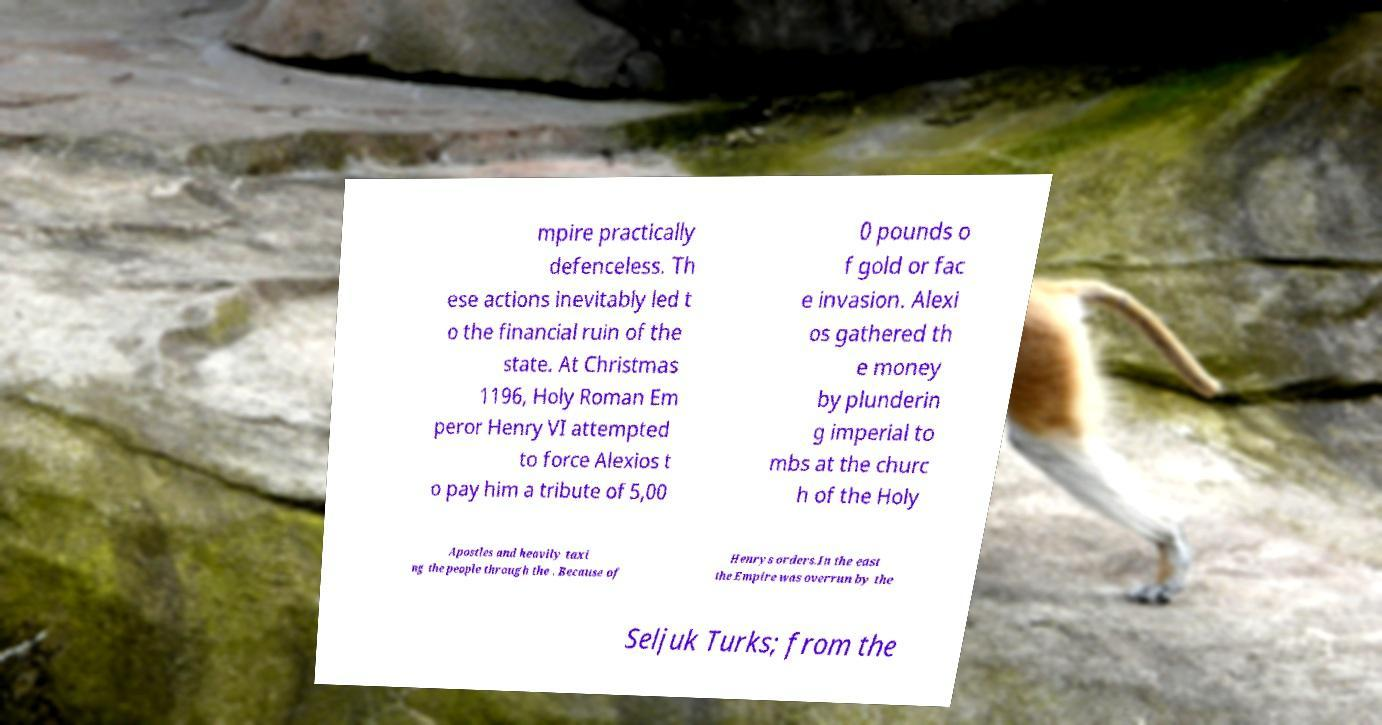Please read and relay the text visible in this image. What does it say? mpire practically defenceless. Th ese actions inevitably led t o the financial ruin of the state. At Christmas 1196, Holy Roman Em peror Henry VI attempted to force Alexios t o pay him a tribute of 5,00 0 pounds o f gold or fac e invasion. Alexi os gathered th e money by plunderin g imperial to mbs at the churc h of the Holy Apostles and heavily taxi ng the people through the . Because of Henrys orders.In the east the Empire was overrun by the Seljuk Turks; from the 